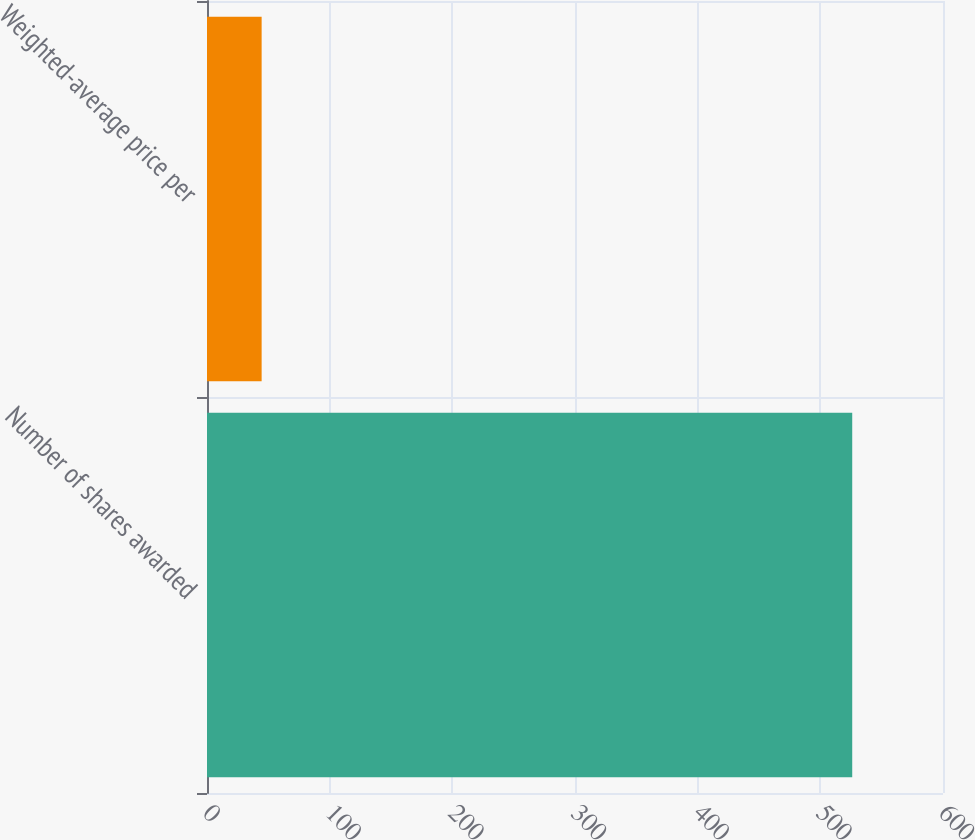Convert chart to OTSL. <chart><loc_0><loc_0><loc_500><loc_500><bar_chart><fcel>Number of shares awarded<fcel>Weighted-average price per<nl><fcel>526<fcel>44.54<nl></chart> 